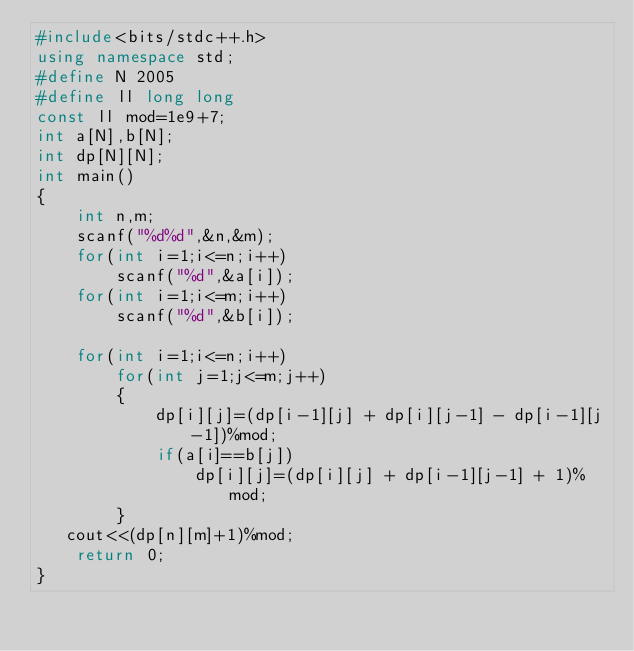Convert code to text. <code><loc_0><loc_0><loc_500><loc_500><_C++_>#include<bits/stdc++.h>
using namespace std;
#define N 2005
#define ll long long
const ll mod=1e9+7;
int a[N],b[N];
int dp[N][N];
int main()
{
    int n,m;
    scanf("%d%d",&n,&m);
    for(int i=1;i<=n;i++)
        scanf("%d",&a[i]);
    for(int i=1;i<=m;i++)
        scanf("%d",&b[i]);

    for(int i=1;i<=n;i++)
        for(int j=1;j<=m;j++)
        {
            dp[i][j]=(dp[i-1][j] + dp[i][j-1] - dp[i-1][j-1])%mod;
            if(a[i]==b[j])
                dp[i][j]=(dp[i][j] + dp[i-1][j-1] + 1)%mod;
        }
   cout<<(dp[n][m]+1)%mod;
    return 0;
}
</code> 